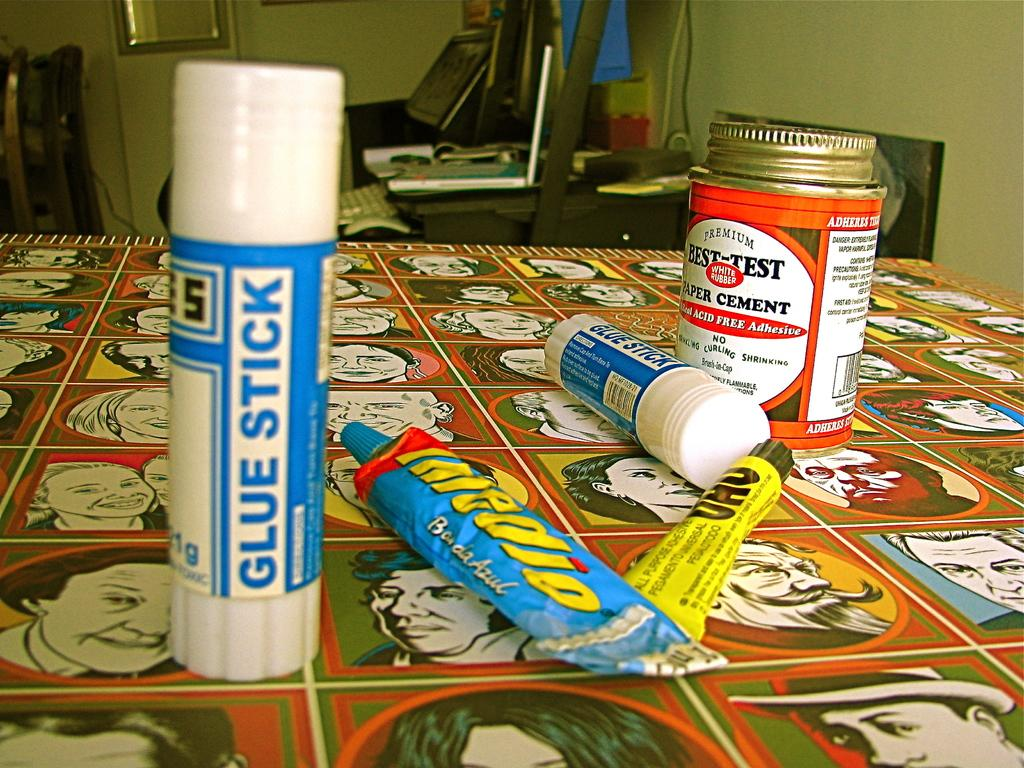<image>
Create a compact narrative representing the image presented. A blue and white glue stick with a can of glue on the table. 